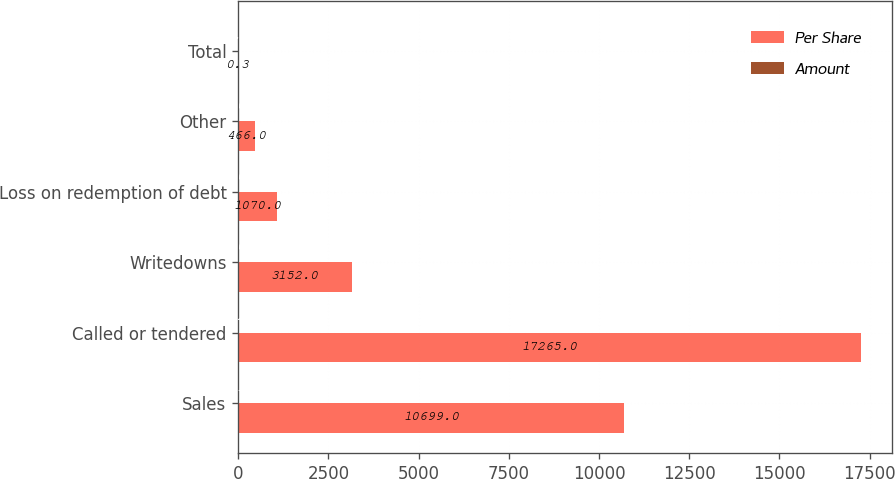Convert chart to OTSL. <chart><loc_0><loc_0><loc_500><loc_500><stacked_bar_chart><ecel><fcel>Sales<fcel>Called or tendered<fcel>Writedowns<fcel>Loss on redemption of debt<fcel>Other<fcel>Total<nl><fcel>Per Share<fcel>10699<fcel>17265<fcel>3152<fcel>1070<fcel>466<fcel>0.3<nl><fcel>Amount<fcel>0.13<fcel>0.21<fcel>0.04<fcel>0.01<fcel>0.01<fcel>0.3<nl></chart> 